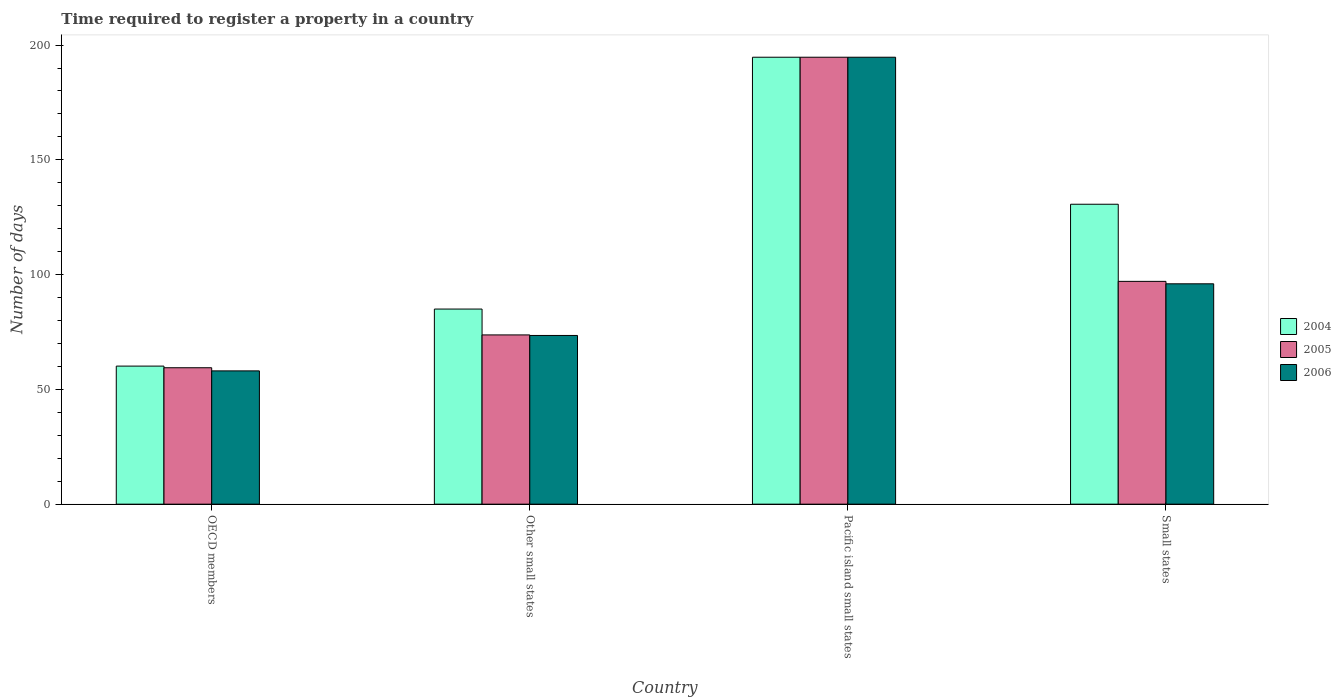How many different coloured bars are there?
Ensure brevity in your answer.  3. Are the number of bars per tick equal to the number of legend labels?
Make the answer very short. Yes. Are the number of bars on each tick of the X-axis equal?
Give a very brief answer. Yes. What is the label of the 2nd group of bars from the left?
Give a very brief answer. Other small states. In how many cases, is the number of bars for a given country not equal to the number of legend labels?
Offer a very short reply. 0. What is the number of days required to register a property in 2004 in Pacific island small states?
Your answer should be very brief. 194.71. Across all countries, what is the maximum number of days required to register a property in 2004?
Provide a succinct answer. 194.71. Across all countries, what is the minimum number of days required to register a property in 2004?
Provide a succinct answer. 60.15. In which country was the number of days required to register a property in 2006 maximum?
Offer a terse response. Pacific island small states. What is the total number of days required to register a property in 2004 in the graph?
Offer a very short reply. 470.53. What is the difference between the number of days required to register a property in 2004 in Other small states and that in Pacific island small states?
Keep it short and to the point. -109.71. What is the difference between the number of days required to register a property in 2004 in Other small states and the number of days required to register a property in 2005 in OECD members?
Keep it short and to the point. 25.57. What is the average number of days required to register a property in 2004 per country?
Offer a terse response. 117.63. What is the difference between the number of days required to register a property of/in 2005 and number of days required to register a property of/in 2006 in Other small states?
Your response must be concise. 0.23. What is the ratio of the number of days required to register a property in 2004 in OECD members to that in Other small states?
Your answer should be compact. 0.71. Is the number of days required to register a property in 2005 in OECD members less than that in Pacific island small states?
Offer a very short reply. Yes. Is the difference between the number of days required to register a property in 2005 in OECD members and Small states greater than the difference between the number of days required to register a property in 2006 in OECD members and Small states?
Your response must be concise. Yes. What is the difference between the highest and the second highest number of days required to register a property in 2004?
Your response must be concise. 109.71. What is the difference between the highest and the lowest number of days required to register a property in 2004?
Your response must be concise. 134.56. Is the sum of the number of days required to register a property in 2006 in Other small states and Small states greater than the maximum number of days required to register a property in 2004 across all countries?
Keep it short and to the point. No. What does the 2nd bar from the left in OECD members represents?
Ensure brevity in your answer.  2005. What does the 2nd bar from the right in OECD members represents?
Offer a very short reply. 2005. How many bars are there?
Make the answer very short. 12. Are all the bars in the graph horizontal?
Your answer should be very brief. No. How many countries are there in the graph?
Make the answer very short. 4. What is the difference between two consecutive major ticks on the Y-axis?
Ensure brevity in your answer.  50. Are the values on the major ticks of Y-axis written in scientific E-notation?
Provide a succinct answer. No. Does the graph contain any zero values?
Your response must be concise. No. How many legend labels are there?
Provide a short and direct response. 3. What is the title of the graph?
Make the answer very short. Time required to register a property in a country. What is the label or title of the Y-axis?
Keep it short and to the point. Number of days. What is the Number of days in 2004 in OECD members?
Your answer should be very brief. 60.15. What is the Number of days in 2005 in OECD members?
Keep it short and to the point. 59.43. What is the Number of days in 2006 in OECD members?
Give a very brief answer. 58.06. What is the Number of days of 2005 in Other small states?
Your answer should be compact. 73.73. What is the Number of days in 2006 in Other small states?
Your answer should be very brief. 73.5. What is the Number of days of 2004 in Pacific island small states?
Provide a short and direct response. 194.71. What is the Number of days of 2005 in Pacific island small states?
Keep it short and to the point. 194.71. What is the Number of days in 2006 in Pacific island small states?
Offer a terse response. 194.71. What is the Number of days of 2004 in Small states?
Make the answer very short. 130.67. What is the Number of days in 2005 in Small states?
Make the answer very short. 97.06. What is the Number of days of 2006 in Small states?
Make the answer very short. 96. Across all countries, what is the maximum Number of days of 2004?
Offer a very short reply. 194.71. Across all countries, what is the maximum Number of days of 2005?
Make the answer very short. 194.71. Across all countries, what is the maximum Number of days in 2006?
Offer a very short reply. 194.71. Across all countries, what is the minimum Number of days of 2004?
Give a very brief answer. 60.15. Across all countries, what is the minimum Number of days in 2005?
Provide a succinct answer. 59.43. Across all countries, what is the minimum Number of days of 2006?
Give a very brief answer. 58.06. What is the total Number of days of 2004 in the graph?
Your answer should be very brief. 470.53. What is the total Number of days of 2005 in the graph?
Offer a very short reply. 424.94. What is the total Number of days of 2006 in the graph?
Ensure brevity in your answer.  422.28. What is the difference between the Number of days in 2004 in OECD members and that in Other small states?
Give a very brief answer. -24.85. What is the difference between the Number of days in 2005 in OECD members and that in Other small states?
Ensure brevity in your answer.  -14.3. What is the difference between the Number of days of 2006 in OECD members and that in Other small states?
Offer a terse response. -15.44. What is the difference between the Number of days of 2004 in OECD members and that in Pacific island small states?
Provide a short and direct response. -134.56. What is the difference between the Number of days of 2005 in OECD members and that in Pacific island small states?
Your answer should be very brief. -135.28. What is the difference between the Number of days of 2006 in OECD members and that in Pacific island small states?
Make the answer very short. -136.65. What is the difference between the Number of days of 2004 in OECD members and that in Small states?
Your response must be concise. -70.52. What is the difference between the Number of days of 2005 in OECD members and that in Small states?
Provide a short and direct response. -37.63. What is the difference between the Number of days in 2006 in OECD members and that in Small states?
Give a very brief answer. -37.94. What is the difference between the Number of days in 2004 in Other small states and that in Pacific island small states?
Provide a succinct answer. -109.71. What is the difference between the Number of days in 2005 in Other small states and that in Pacific island small states?
Provide a short and direct response. -120.98. What is the difference between the Number of days in 2006 in Other small states and that in Pacific island small states?
Ensure brevity in your answer.  -121.21. What is the difference between the Number of days of 2004 in Other small states and that in Small states?
Your response must be concise. -45.67. What is the difference between the Number of days of 2005 in Other small states and that in Small states?
Offer a terse response. -23.33. What is the difference between the Number of days in 2006 in Other small states and that in Small states?
Your answer should be compact. -22.5. What is the difference between the Number of days of 2004 in Pacific island small states and that in Small states?
Give a very brief answer. 64.05. What is the difference between the Number of days in 2005 in Pacific island small states and that in Small states?
Your answer should be very brief. 97.65. What is the difference between the Number of days in 2006 in Pacific island small states and that in Small states?
Your response must be concise. 98.71. What is the difference between the Number of days of 2004 in OECD members and the Number of days of 2005 in Other small states?
Your response must be concise. -13.58. What is the difference between the Number of days in 2004 in OECD members and the Number of days in 2006 in Other small states?
Your response must be concise. -13.35. What is the difference between the Number of days of 2005 in OECD members and the Number of days of 2006 in Other small states?
Offer a very short reply. -14.07. What is the difference between the Number of days in 2004 in OECD members and the Number of days in 2005 in Pacific island small states?
Provide a succinct answer. -134.56. What is the difference between the Number of days in 2004 in OECD members and the Number of days in 2006 in Pacific island small states?
Ensure brevity in your answer.  -134.56. What is the difference between the Number of days of 2005 in OECD members and the Number of days of 2006 in Pacific island small states?
Your answer should be very brief. -135.28. What is the difference between the Number of days in 2004 in OECD members and the Number of days in 2005 in Small states?
Offer a very short reply. -36.91. What is the difference between the Number of days in 2004 in OECD members and the Number of days in 2006 in Small states?
Keep it short and to the point. -35.85. What is the difference between the Number of days of 2005 in OECD members and the Number of days of 2006 in Small states?
Provide a succinct answer. -36.57. What is the difference between the Number of days in 2004 in Other small states and the Number of days in 2005 in Pacific island small states?
Your response must be concise. -109.71. What is the difference between the Number of days in 2004 in Other small states and the Number of days in 2006 in Pacific island small states?
Give a very brief answer. -109.71. What is the difference between the Number of days of 2005 in Other small states and the Number of days of 2006 in Pacific island small states?
Offer a very short reply. -120.98. What is the difference between the Number of days of 2004 in Other small states and the Number of days of 2005 in Small states?
Offer a terse response. -12.06. What is the difference between the Number of days in 2004 in Other small states and the Number of days in 2006 in Small states?
Your answer should be very brief. -11. What is the difference between the Number of days of 2005 in Other small states and the Number of days of 2006 in Small states?
Provide a short and direct response. -22.27. What is the difference between the Number of days of 2004 in Pacific island small states and the Number of days of 2005 in Small states?
Give a very brief answer. 97.65. What is the difference between the Number of days of 2004 in Pacific island small states and the Number of days of 2006 in Small states?
Provide a succinct answer. 98.71. What is the difference between the Number of days in 2005 in Pacific island small states and the Number of days in 2006 in Small states?
Provide a succinct answer. 98.71. What is the average Number of days of 2004 per country?
Provide a succinct answer. 117.63. What is the average Number of days in 2005 per country?
Keep it short and to the point. 106.24. What is the average Number of days in 2006 per country?
Your response must be concise. 105.57. What is the difference between the Number of days of 2004 and Number of days of 2005 in OECD members?
Keep it short and to the point. 0.72. What is the difference between the Number of days of 2004 and Number of days of 2006 in OECD members?
Your answer should be compact. 2.09. What is the difference between the Number of days in 2005 and Number of days in 2006 in OECD members?
Offer a terse response. 1.37. What is the difference between the Number of days in 2004 and Number of days in 2005 in Other small states?
Provide a succinct answer. 11.27. What is the difference between the Number of days of 2004 and Number of days of 2006 in Other small states?
Offer a terse response. 11.5. What is the difference between the Number of days in 2005 and Number of days in 2006 in Other small states?
Make the answer very short. 0.23. What is the difference between the Number of days in 2004 and Number of days in 2005 in Pacific island small states?
Provide a short and direct response. 0. What is the difference between the Number of days of 2004 and Number of days of 2005 in Small states?
Ensure brevity in your answer.  33.61. What is the difference between the Number of days in 2004 and Number of days in 2006 in Small states?
Your response must be concise. 34.67. What is the difference between the Number of days of 2005 and Number of days of 2006 in Small states?
Keep it short and to the point. 1.06. What is the ratio of the Number of days in 2004 in OECD members to that in Other small states?
Make the answer very short. 0.71. What is the ratio of the Number of days in 2005 in OECD members to that in Other small states?
Ensure brevity in your answer.  0.81. What is the ratio of the Number of days in 2006 in OECD members to that in Other small states?
Your response must be concise. 0.79. What is the ratio of the Number of days of 2004 in OECD members to that in Pacific island small states?
Your answer should be very brief. 0.31. What is the ratio of the Number of days of 2005 in OECD members to that in Pacific island small states?
Keep it short and to the point. 0.31. What is the ratio of the Number of days of 2006 in OECD members to that in Pacific island small states?
Your response must be concise. 0.3. What is the ratio of the Number of days of 2004 in OECD members to that in Small states?
Your answer should be compact. 0.46. What is the ratio of the Number of days in 2005 in OECD members to that in Small states?
Ensure brevity in your answer.  0.61. What is the ratio of the Number of days of 2006 in OECD members to that in Small states?
Offer a very short reply. 0.6. What is the ratio of the Number of days in 2004 in Other small states to that in Pacific island small states?
Give a very brief answer. 0.44. What is the ratio of the Number of days in 2005 in Other small states to that in Pacific island small states?
Keep it short and to the point. 0.38. What is the ratio of the Number of days in 2006 in Other small states to that in Pacific island small states?
Keep it short and to the point. 0.38. What is the ratio of the Number of days in 2004 in Other small states to that in Small states?
Offer a very short reply. 0.65. What is the ratio of the Number of days of 2005 in Other small states to that in Small states?
Provide a short and direct response. 0.76. What is the ratio of the Number of days in 2006 in Other small states to that in Small states?
Offer a terse response. 0.77. What is the ratio of the Number of days of 2004 in Pacific island small states to that in Small states?
Ensure brevity in your answer.  1.49. What is the ratio of the Number of days of 2005 in Pacific island small states to that in Small states?
Offer a terse response. 2.01. What is the ratio of the Number of days of 2006 in Pacific island small states to that in Small states?
Keep it short and to the point. 2.03. What is the difference between the highest and the second highest Number of days of 2004?
Your response must be concise. 64.05. What is the difference between the highest and the second highest Number of days in 2005?
Make the answer very short. 97.65. What is the difference between the highest and the second highest Number of days in 2006?
Give a very brief answer. 98.71. What is the difference between the highest and the lowest Number of days in 2004?
Offer a very short reply. 134.56. What is the difference between the highest and the lowest Number of days of 2005?
Your answer should be compact. 135.28. What is the difference between the highest and the lowest Number of days of 2006?
Ensure brevity in your answer.  136.65. 